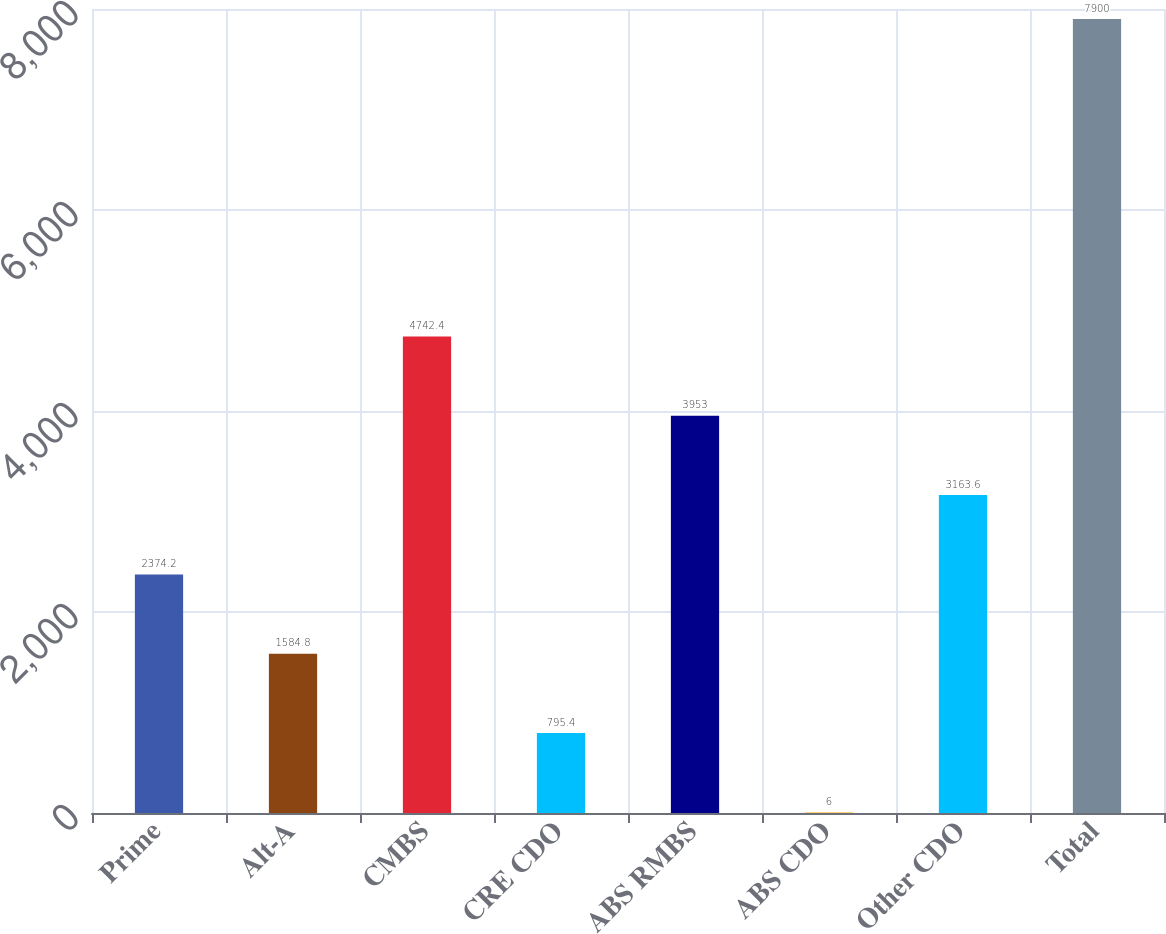Convert chart to OTSL. <chart><loc_0><loc_0><loc_500><loc_500><bar_chart><fcel>Prime<fcel>Alt-A<fcel>CMBS<fcel>CRE CDO<fcel>ABS RMBS<fcel>ABS CDO<fcel>Other CDO<fcel>Total<nl><fcel>2374.2<fcel>1584.8<fcel>4742.4<fcel>795.4<fcel>3953<fcel>6<fcel>3163.6<fcel>7900<nl></chart> 